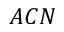<formula> <loc_0><loc_0><loc_500><loc_500>A C N</formula> 